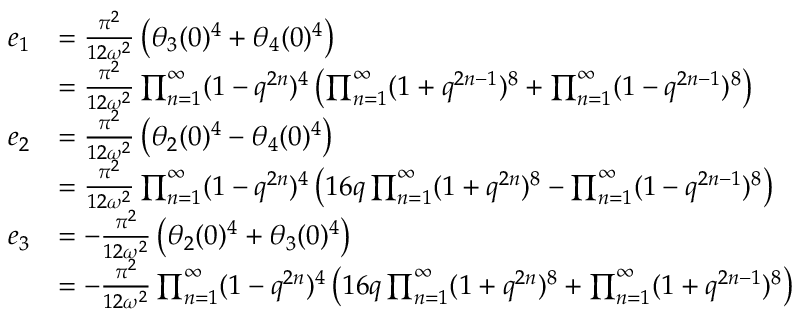<formula> <loc_0><loc_0><loc_500><loc_500>\begin{array} { r l } { { e _ { 1 } } } & { { = { \frac { \pi ^ { 2 } } { 1 2 \omega ^ { 2 } } } \left ( \theta _ { 3 } ( 0 ) ^ { 4 } + \theta _ { 4 } ( 0 ) ^ { 4 } \right ) } } & { { = { \frac { \pi ^ { 2 } } { 1 2 \omega ^ { 2 } } } \prod _ { n = 1 } ^ { \infty } ( 1 - q ^ { 2 n } ) ^ { 4 } \left ( \prod _ { n = 1 } ^ { \infty } ( 1 + q ^ { 2 n - 1 } ) ^ { 8 } + \prod _ { n = 1 } ^ { \infty } ( 1 - q ^ { 2 n - 1 } ) ^ { 8 } \right ) } } \\ { { e _ { 2 } } } & { { = { \frac { \pi ^ { 2 } } { 1 2 \omega ^ { 2 } } } \left ( \theta _ { 2 } ( 0 ) ^ { 4 } - \theta _ { 4 } ( 0 ) ^ { 4 } \right ) } } & { { = { \frac { \pi ^ { 2 } } { 1 2 \omega ^ { 2 } } } \prod _ { n = 1 } ^ { \infty } ( 1 - q ^ { 2 n } ) ^ { 4 } \left ( 1 6 q \prod _ { n = 1 } ^ { \infty } ( 1 + q ^ { 2 n } ) ^ { 8 } - \prod _ { n = 1 } ^ { \infty } ( 1 - q ^ { 2 n - 1 } ) ^ { 8 } \right ) } } \\ { { e _ { 3 } } } & { { = - { \frac { \pi ^ { 2 } } { 1 2 \omega ^ { 2 } } } \left ( \theta _ { 2 } ( 0 ) ^ { 4 } + \theta _ { 3 } ( 0 ) ^ { 4 } \right ) } } & { { = - { \frac { \pi ^ { 2 } } { 1 2 \omega ^ { 2 } } } \prod _ { n = 1 } ^ { \infty } ( 1 - q ^ { 2 n } ) ^ { 4 } \left ( 1 6 q \prod _ { n = 1 } ^ { \infty } ( 1 + q ^ { 2 n } ) ^ { 8 } + \prod _ { n = 1 } ^ { \infty } ( 1 + q ^ { 2 n - 1 } ) ^ { 8 } \right ) } } \end{array}</formula> 